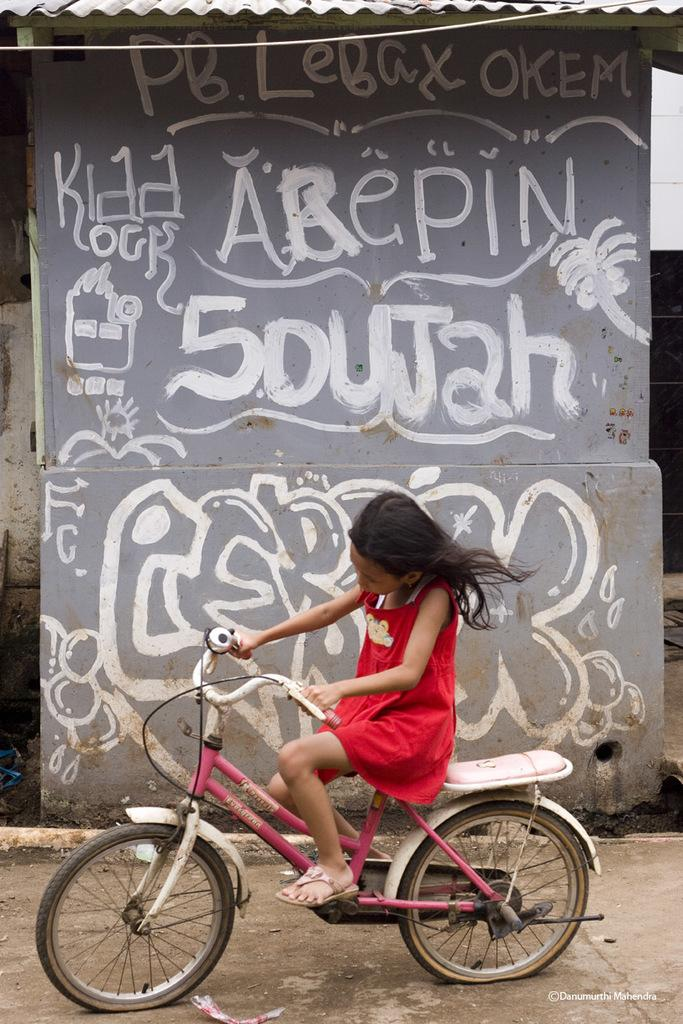Who is the main subject in the image? There is a girl in the image. What is the girl wearing? The girl is wearing a red dress. What is the girl doing in the image? The girl is riding a pink bicycle. What can be seen on the wall beside the girl? There is something written on the wall beside her. What type of thrill can be seen on the girl's face while riding the bed in the image? There is no bed present in the image, and the girl is riding a pink bicycle, not a bed. 